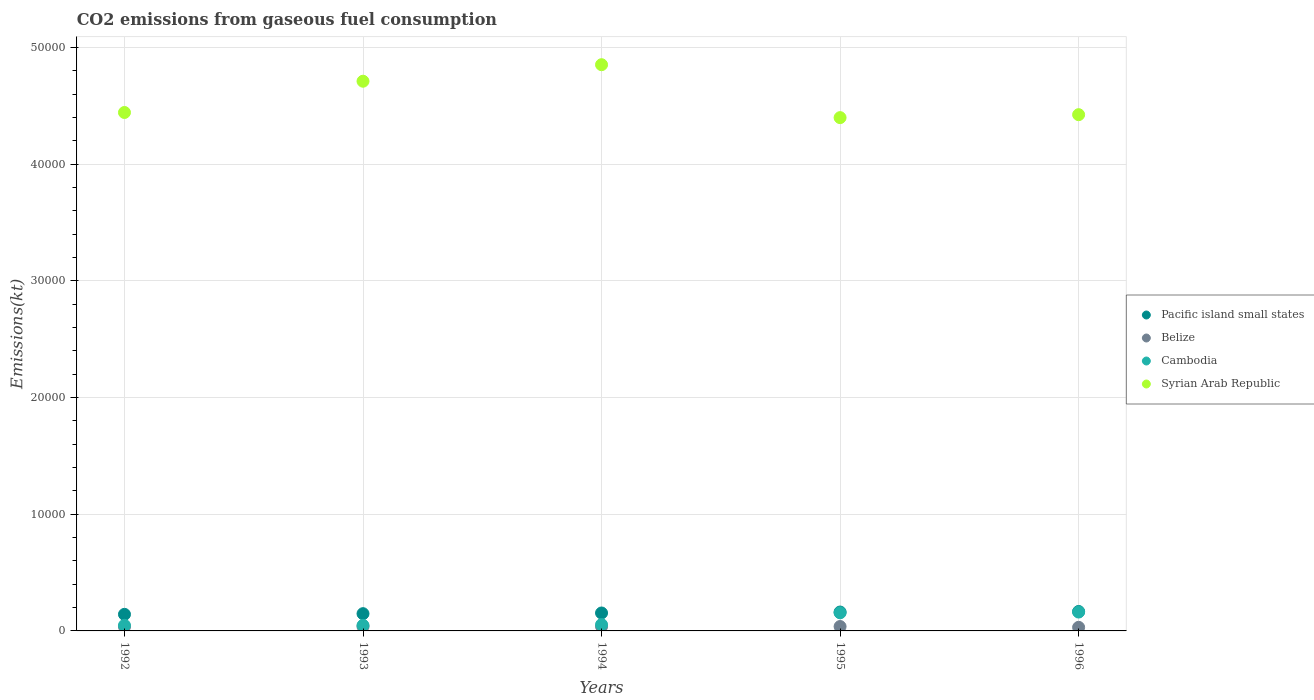Is the number of dotlines equal to the number of legend labels?
Your answer should be very brief. Yes. What is the amount of CO2 emitted in Syrian Arab Republic in 1993?
Offer a terse response. 4.71e+04. Across all years, what is the maximum amount of CO2 emitted in Syrian Arab Republic?
Your answer should be compact. 4.85e+04. Across all years, what is the minimum amount of CO2 emitted in Cambodia?
Keep it short and to the point. 476.71. In which year was the amount of CO2 emitted in Syrian Arab Republic maximum?
Make the answer very short. 1994. What is the total amount of CO2 emitted in Cambodia in the graph?
Keep it short and to the point. 4660.76. What is the difference between the amount of CO2 emitted in Belize in 1993 and that in 1994?
Provide a short and direct response. 3.67. What is the difference between the amount of CO2 emitted in Belize in 1993 and the amount of CO2 emitted in Cambodia in 1992?
Ensure brevity in your answer.  -99.01. What is the average amount of CO2 emitted in Pacific island small states per year?
Your response must be concise. 1544.2. In the year 1992, what is the difference between the amount of CO2 emitted in Pacific island small states and amount of CO2 emitted in Cambodia?
Your answer should be compact. 943.74. In how many years, is the amount of CO2 emitted in Syrian Arab Republic greater than 4000 kt?
Provide a succinct answer. 5. What is the ratio of the amount of CO2 emitted in Belize in 1992 to that in 1995?
Offer a very short reply. 0.94. Is the amount of CO2 emitted in Syrian Arab Republic in 1993 less than that in 1994?
Offer a very short reply. Yes. Is the difference between the amount of CO2 emitted in Pacific island small states in 1993 and 1995 greater than the difference between the amount of CO2 emitted in Cambodia in 1993 and 1995?
Offer a very short reply. Yes. What is the difference between the highest and the second highest amount of CO2 emitted in Belize?
Your answer should be compact. 0. What is the difference between the highest and the lowest amount of CO2 emitted in Pacific island small states?
Give a very brief answer. 245.17. Is the sum of the amount of CO2 emitted in Cambodia in 1992 and 1993 greater than the maximum amount of CO2 emitted in Belize across all years?
Your answer should be compact. Yes. Is it the case that in every year, the sum of the amount of CO2 emitted in Syrian Arab Republic and amount of CO2 emitted in Pacific island small states  is greater than the sum of amount of CO2 emitted in Cambodia and amount of CO2 emitted in Belize?
Provide a short and direct response. Yes. Is it the case that in every year, the sum of the amount of CO2 emitted in Syrian Arab Republic and amount of CO2 emitted in Pacific island small states  is greater than the amount of CO2 emitted in Cambodia?
Provide a succinct answer. Yes. Does the amount of CO2 emitted in Pacific island small states monotonically increase over the years?
Your response must be concise. Yes. Is the amount of CO2 emitted in Pacific island small states strictly greater than the amount of CO2 emitted in Syrian Arab Republic over the years?
Offer a very short reply. No. How many years are there in the graph?
Ensure brevity in your answer.  5. What is the difference between two consecutive major ticks on the Y-axis?
Ensure brevity in your answer.  10000. Does the graph contain any zero values?
Provide a short and direct response. No. Where does the legend appear in the graph?
Offer a terse response. Center right. How are the legend labels stacked?
Make the answer very short. Vertical. What is the title of the graph?
Offer a very short reply. CO2 emissions from gaseous fuel consumption. Does "Jamaica" appear as one of the legend labels in the graph?
Your response must be concise. No. What is the label or title of the X-axis?
Your response must be concise. Years. What is the label or title of the Y-axis?
Your answer should be compact. Emissions(kt). What is the Emissions(kt) in Pacific island small states in 1992?
Provide a short and direct response. 1420.45. What is the Emissions(kt) in Belize in 1992?
Ensure brevity in your answer.  355.7. What is the Emissions(kt) of Cambodia in 1992?
Make the answer very short. 476.71. What is the Emissions(kt) of Syrian Arab Republic in 1992?
Your response must be concise. 4.44e+04. What is the Emissions(kt) in Pacific island small states in 1993?
Ensure brevity in your answer.  1478.82. What is the Emissions(kt) of Belize in 1993?
Offer a very short reply. 377.7. What is the Emissions(kt) in Cambodia in 1993?
Your response must be concise. 476.71. What is the Emissions(kt) in Syrian Arab Republic in 1993?
Offer a terse response. 4.71e+04. What is the Emissions(kt) of Pacific island small states in 1994?
Your answer should be very brief. 1537.2. What is the Emissions(kt) in Belize in 1994?
Your response must be concise. 374.03. What is the Emissions(kt) of Cambodia in 1994?
Make the answer very short. 539.05. What is the Emissions(kt) in Syrian Arab Republic in 1994?
Provide a short and direct response. 4.85e+04. What is the Emissions(kt) of Pacific island small states in 1995?
Ensure brevity in your answer.  1618.92. What is the Emissions(kt) in Belize in 1995?
Offer a very short reply. 377.7. What is the Emissions(kt) in Cambodia in 1995?
Your answer should be compact. 1551.14. What is the Emissions(kt) of Syrian Arab Republic in 1995?
Your answer should be compact. 4.40e+04. What is the Emissions(kt) in Pacific island small states in 1996?
Keep it short and to the point. 1665.62. What is the Emissions(kt) of Belize in 1996?
Provide a short and direct response. 308.03. What is the Emissions(kt) of Cambodia in 1996?
Give a very brief answer. 1617.15. What is the Emissions(kt) of Syrian Arab Republic in 1996?
Make the answer very short. 4.42e+04. Across all years, what is the maximum Emissions(kt) of Pacific island small states?
Offer a terse response. 1665.62. Across all years, what is the maximum Emissions(kt) of Belize?
Provide a succinct answer. 377.7. Across all years, what is the maximum Emissions(kt) in Cambodia?
Offer a terse response. 1617.15. Across all years, what is the maximum Emissions(kt) in Syrian Arab Republic?
Make the answer very short. 4.85e+04. Across all years, what is the minimum Emissions(kt) of Pacific island small states?
Offer a very short reply. 1420.45. Across all years, what is the minimum Emissions(kt) of Belize?
Offer a terse response. 308.03. Across all years, what is the minimum Emissions(kt) in Cambodia?
Give a very brief answer. 476.71. Across all years, what is the minimum Emissions(kt) of Syrian Arab Republic?
Ensure brevity in your answer.  4.40e+04. What is the total Emissions(kt) in Pacific island small states in the graph?
Give a very brief answer. 7721.02. What is the total Emissions(kt) of Belize in the graph?
Your answer should be very brief. 1793.16. What is the total Emissions(kt) of Cambodia in the graph?
Offer a very short reply. 4660.76. What is the total Emissions(kt) in Syrian Arab Republic in the graph?
Your answer should be compact. 2.28e+05. What is the difference between the Emissions(kt) in Pacific island small states in 1992 and that in 1993?
Ensure brevity in your answer.  -58.37. What is the difference between the Emissions(kt) of Belize in 1992 and that in 1993?
Ensure brevity in your answer.  -22. What is the difference between the Emissions(kt) in Cambodia in 1992 and that in 1993?
Your answer should be very brief. 0. What is the difference between the Emissions(kt) in Syrian Arab Republic in 1992 and that in 1993?
Offer a very short reply. -2680.58. What is the difference between the Emissions(kt) in Pacific island small states in 1992 and that in 1994?
Your answer should be very brief. -116.75. What is the difference between the Emissions(kt) of Belize in 1992 and that in 1994?
Your answer should be compact. -18.34. What is the difference between the Emissions(kt) in Cambodia in 1992 and that in 1994?
Provide a succinct answer. -62.34. What is the difference between the Emissions(kt) in Syrian Arab Republic in 1992 and that in 1994?
Provide a short and direct response. -4096.04. What is the difference between the Emissions(kt) in Pacific island small states in 1992 and that in 1995?
Offer a very short reply. -198.47. What is the difference between the Emissions(kt) of Belize in 1992 and that in 1995?
Make the answer very short. -22. What is the difference between the Emissions(kt) in Cambodia in 1992 and that in 1995?
Ensure brevity in your answer.  -1074.43. What is the difference between the Emissions(kt) in Syrian Arab Republic in 1992 and that in 1995?
Provide a succinct answer. 440.04. What is the difference between the Emissions(kt) of Pacific island small states in 1992 and that in 1996?
Ensure brevity in your answer.  -245.17. What is the difference between the Emissions(kt) of Belize in 1992 and that in 1996?
Provide a short and direct response. 47.67. What is the difference between the Emissions(kt) of Cambodia in 1992 and that in 1996?
Your response must be concise. -1140.44. What is the difference between the Emissions(kt) in Syrian Arab Republic in 1992 and that in 1996?
Your answer should be compact. 187.02. What is the difference between the Emissions(kt) of Pacific island small states in 1993 and that in 1994?
Your answer should be very brief. -58.37. What is the difference between the Emissions(kt) in Belize in 1993 and that in 1994?
Provide a succinct answer. 3.67. What is the difference between the Emissions(kt) of Cambodia in 1993 and that in 1994?
Provide a succinct answer. -62.34. What is the difference between the Emissions(kt) of Syrian Arab Republic in 1993 and that in 1994?
Give a very brief answer. -1415.46. What is the difference between the Emissions(kt) in Pacific island small states in 1993 and that in 1995?
Keep it short and to the point. -140.1. What is the difference between the Emissions(kt) of Cambodia in 1993 and that in 1995?
Offer a terse response. -1074.43. What is the difference between the Emissions(kt) of Syrian Arab Republic in 1993 and that in 1995?
Your response must be concise. 3120.62. What is the difference between the Emissions(kt) in Pacific island small states in 1993 and that in 1996?
Provide a short and direct response. -186.8. What is the difference between the Emissions(kt) in Belize in 1993 and that in 1996?
Provide a short and direct response. 69.67. What is the difference between the Emissions(kt) in Cambodia in 1993 and that in 1996?
Offer a very short reply. -1140.44. What is the difference between the Emissions(kt) of Syrian Arab Republic in 1993 and that in 1996?
Offer a very short reply. 2867.59. What is the difference between the Emissions(kt) in Pacific island small states in 1994 and that in 1995?
Offer a terse response. -81.72. What is the difference between the Emissions(kt) of Belize in 1994 and that in 1995?
Your answer should be compact. -3.67. What is the difference between the Emissions(kt) in Cambodia in 1994 and that in 1995?
Ensure brevity in your answer.  -1012.09. What is the difference between the Emissions(kt) of Syrian Arab Republic in 1994 and that in 1995?
Ensure brevity in your answer.  4536.08. What is the difference between the Emissions(kt) of Pacific island small states in 1994 and that in 1996?
Provide a short and direct response. -128.42. What is the difference between the Emissions(kt) of Belize in 1994 and that in 1996?
Your response must be concise. 66.01. What is the difference between the Emissions(kt) in Cambodia in 1994 and that in 1996?
Make the answer very short. -1078.1. What is the difference between the Emissions(kt) in Syrian Arab Republic in 1994 and that in 1996?
Give a very brief answer. 4283.06. What is the difference between the Emissions(kt) of Pacific island small states in 1995 and that in 1996?
Ensure brevity in your answer.  -46.7. What is the difference between the Emissions(kt) in Belize in 1995 and that in 1996?
Offer a very short reply. 69.67. What is the difference between the Emissions(kt) of Cambodia in 1995 and that in 1996?
Ensure brevity in your answer.  -66.01. What is the difference between the Emissions(kt) of Syrian Arab Republic in 1995 and that in 1996?
Your answer should be compact. -253.02. What is the difference between the Emissions(kt) in Pacific island small states in 1992 and the Emissions(kt) in Belize in 1993?
Provide a succinct answer. 1042.75. What is the difference between the Emissions(kt) of Pacific island small states in 1992 and the Emissions(kt) of Cambodia in 1993?
Provide a short and direct response. 943.74. What is the difference between the Emissions(kt) of Pacific island small states in 1992 and the Emissions(kt) of Syrian Arab Republic in 1993?
Provide a short and direct response. -4.57e+04. What is the difference between the Emissions(kt) in Belize in 1992 and the Emissions(kt) in Cambodia in 1993?
Provide a short and direct response. -121.01. What is the difference between the Emissions(kt) in Belize in 1992 and the Emissions(kt) in Syrian Arab Republic in 1993?
Make the answer very short. -4.68e+04. What is the difference between the Emissions(kt) in Cambodia in 1992 and the Emissions(kt) in Syrian Arab Republic in 1993?
Your response must be concise. -4.66e+04. What is the difference between the Emissions(kt) of Pacific island small states in 1992 and the Emissions(kt) of Belize in 1994?
Make the answer very short. 1046.42. What is the difference between the Emissions(kt) in Pacific island small states in 1992 and the Emissions(kt) in Cambodia in 1994?
Offer a terse response. 881.4. What is the difference between the Emissions(kt) of Pacific island small states in 1992 and the Emissions(kt) of Syrian Arab Republic in 1994?
Ensure brevity in your answer.  -4.71e+04. What is the difference between the Emissions(kt) in Belize in 1992 and the Emissions(kt) in Cambodia in 1994?
Ensure brevity in your answer.  -183.35. What is the difference between the Emissions(kt) of Belize in 1992 and the Emissions(kt) of Syrian Arab Republic in 1994?
Give a very brief answer. -4.82e+04. What is the difference between the Emissions(kt) in Cambodia in 1992 and the Emissions(kt) in Syrian Arab Republic in 1994?
Provide a short and direct response. -4.81e+04. What is the difference between the Emissions(kt) of Pacific island small states in 1992 and the Emissions(kt) of Belize in 1995?
Provide a short and direct response. 1042.75. What is the difference between the Emissions(kt) of Pacific island small states in 1992 and the Emissions(kt) of Cambodia in 1995?
Keep it short and to the point. -130.69. What is the difference between the Emissions(kt) of Pacific island small states in 1992 and the Emissions(kt) of Syrian Arab Republic in 1995?
Offer a very short reply. -4.26e+04. What is the difference between the Emissions(kt) of Belize in 1992 and the Emissions(kt) of Cambodia in 1995?
Provide a short and direct response. -1195.44. What is the difference between the Emissions(kt) of Belize in 1992 and the Emissions(kt) of Syrian Arab Republic in 1995?
Offer a terse response. -4.36e+04. What is the difference between the Emissions(kt) of Cambodia in 1992 and the Emissions(kt) of Syrian Arab Republic in 1995?
Make the answer very short. -4.35e+04. What is the difference between the Emissions(kt) in Pacific island small states in 1992 and the Emissions(kt) in Belize in 1996?
Keep it short and to the point. 1112.42. What is the difference between the Emissions(kt) of Pacific island small states in 1992 and the Emissions(kt) of Cambodia in 1996?
Give a very brief answer. -196.7. What is the difference between the Emissions(kt) of Pacific island small states in 1992 and the Emissions(kt) of Syrian Arab Republic in 1996?
Offer a terse response. -4.28e+04. What is the difference between the Emissions(kt) of Belize in 1992 and the Emissions(kt) of Cambodia in 1996?
Your answer should be very brief. -1261.45. What is the difference between the Emissions(kt) of Belize in 1992 and the Emissions(kt) of Syrian Arab Republic in 1996?
Your response must be concise. -4.39e+04. What is the difference between the Emissions(kt) in Cambodia in 1992 and the Emissions(kt) in Syrian Arab Republic in 1996?
Your response must be concise. -4.38e+04. What is the difference between the Emissions(kt) of Pacific island small states in 1993 and the Emissions(kt) of Belize in 1994?
Your answer should be very brief. 1104.79. What is the difference between the Emissions(kt) of Pacific island small states in 1993 and the Emissions(kt) of Cambodia in 1994?
Ensure brevity in your answer.  939.78. What is the difference between the Emissions(kt) in Pacific island small states in 1993 and the Emissions(kt) in Syrian Arab Republic in 1994?
Your answer should be very brief. -4.71e+04. What is the difference between the Emissions(kt) of Belize in 1993 and the Emissions(kt) of Cambodia in 1994?
Provide a succinct answer. -161.35. What is the difference between the Emissions(kt) of Belize in 1993 and the Emissions(kt) of Syrian Arab Republic in 1994?
Provide a succinct answer. -4.82e+04. What is the difference between the Emissions(kt) in Cambodia in 1993 and the Emissions(kt) in Syrian Arab Republic in 1994?
Give a very brief answer. -4.81e+04. What is the difference between the Emissions(kt) in Pacific island small states in 1993 and the Emissions(kt) in Belize in 1995?
Make the answer very short. 1101.12. What is the difference between the Emissions(kt) of Pacific island small states in 1993 and the Emissions(kt) of Cambodia in 1995?
Provide a short and direct response. -72.32. What is the difference between the Emissions(kt) in Pacific island small states in 1993 and the Emissions(kt) in Syrian Arab Republic in 1995?
Offer a terse response. -4.25e+04. What is the difference between the Emissions(kt) in Belize in 1993 and the Emissions(kt) in Cambodia in 1995?
Your response must be concise. -1173.44. What is the difference between the Emissions(kt) in Belize in 1993 and the Emissions(kt) in Syrian Arab Republic in 1995?
Provide a succinct answer. -4.36e+04. What is the difference between the Emissions(kt) in Cambodia in 1993 and the Emissions(kt) in Syrian Arab Republic in 1995?
Provide a succinct answer. -4.35e+04. What is the difference between the Emissions(kt) in Pacific island small states in 1993 and the Emissions(kt) in Belize in 1996?
Provide a succinct answer. 1170.8. What is the difference between the Emissions(kt) of Pacific island small states in 1993 and the Emissions(kt) of Cambodia in 1996?
Offer a very short reply. -138.32. What is the difference between the Emissions(kt) of Pacific island small states in 1993 and the Emissions(kt) of Syrian Arab Republic in 1996?
Your answer should be very brief. -4.28e+04. What is the difference between the Emissions(kt) of Belize in 1993 and the Emissions(kt) of Cambodia in 1996?
Your answer should be very brief. -1239.45. What is the difference between the Emissions(kt) of Belize in 1993 and the Emissions(kt) of Syrian Arab Republic in 1996?
Ensure brevity in your answer.  -4.39e+04. What is the difference between the Emissions(kt) in Cambodia in 1993 and the Emissions(kt) in Syrian Arab Republic in 1996?
Offer a terse response. -4.38e+04. What is the difference between the Emissions(kt) of Pacific island small states in 1994 and the Emissions(kt) of Belize in 1995?
Your answer should be very brief. 1159.5. What is the difference between the Emissions(kt) in Pacific island small states in 1994 and the Emissions(kt) in Cambodia in 1995?
Provide a succinct answer. -13.94. What is the difference between the Emissions(kt) of Pacific island small states in 1994 and the Emissions(kt) of Syrian Arab Republic in 1995?
Provide a short and direct response. -4.25e+04. What is the difference between the Emissions(kt) in Belize in 1994 and the Emissions(kt) in Cambodia in 1995?
Your response must be concise. -1177.11. What is the difference between the Emissions(kt) of Belize in 1994 and the Emissions(kt) of Syrian Arab Republic in 1995?
Offer a very short reply. -4.36e+04. What is the difference between the Emissions(kt) of Cambodia in 1994 and the Emissions(kt) of Syrian Arab Republic in 1995?
Offer a very short reply. -4.35e+04. What is the difference between the Emissions(kt) of Pacific island small states in 1994 and the Emissions(kt) of Belize in 1996?
Provide a short and direct response. 1229.17. What is the difference between the Emissions(kt) in Pacific island small states in 1994 and the Emissions(kt) in Cambodia in 1996?
Give a very brief answer. -79.95. What is the difference between the Emissions(kt) of Pacific island small states in 1994 and the Emissions(kt) of Syrian Arab Republic in 1996?
Make the answer very short. -4.27e+04. What is the difference between the Emissions(kt) in Belize in 1994 and the Emissions(kt) in Cambodia in 1996?
Your answer should be compact. -1243.11. What is the difference between the Emissions(kt) of Belize in 1994 and the Emissions(kt) of Syrian Arab Republic in 1996?
Make the answer very short. -4.39e+04. What is the difference between the Emissions(kt) of Cambodia in 1994 and the Emissions(kt) of Syrian Arab Republic in 1996?
Keep it short and to the point. -4.37e+04. What is the difference between the Emissions(kt) in Pacific island small states in 1995 and the Emissions(kt) in Belize in 1996?
Provide a succinct answer. 1310.9. What is the difference between the Emissions(kt) in Pacific island small states in 1995 and the Emissions(kt) in Cambodia in 1996?
Offer a very short reply. 1.78. What is the difference between the Emissions(kt) in Pacific island small states in 1995 and the Emissions(kt) in Syrian Arab Republic in 1996?
Your answer should be very brief. -4.26e+04. What is the difference between the Emissions(kt) in Belize in 1995 and the Emissions(kt) in Cambodia in 1996?
Your answer should be compact. -1239.45. What is the difference between the Emissions(kt) in Belize in 1995 and the Emissions(kt) in Syrian Arab Republic in 1996?
Keep it short and to the point. -4.39e+04. What is the difference between the Emissions(kt) in Cambodia in 1995 and the Emissions(kt) in Syrian Arab Republic in 1996?
Your response must be concise. -4.27e+04. What is the average Emissions(kt) in Pacific island small states per year?
Offer a very short reply. 1544.2. What is the average Emissions(kt) in Belize per year?
Make the answer very short. 358.63. What is the average Emissions(kt) of Cambodia per year?
Offer a terse response. 932.15. What is the average Emissions(kt) in Syrian Arab Republic per year?
Keep it short and to the point. 4.57e+04. In the year 1992, what is the difference between the Emissions(kt) in Pacific island small states and Emissions(kt) in Belize?
Give a very brief answer. 1064.75. In the year 1992, what is the difference between the Emissions(kt) in Pacific island small states and Emissions(kt) in Cambodia?
Your answer should be very brief. 943.74. In the year 1992, what is the difference between the Emissions(kt) in Pacific island small states and Emissions(kt) in Syrian Arab Republic?
Offer a very short reply. -4.30e+04. In the year 1992, what is the difference between the Emissions(kt) in Belize and Emissions(kt) in Cambodia?
Your answer should be very brief. -121.01. In the year 1992, what is the difference between the Emissions(kt) in Belize and Emissions(kt) in Syrian Arab Republic?
Your response must be concise. -4.41e+04. In the year 1992, what is the difference between the Emissions(kt) in Cambodia and Emissions(kt) in Syrian Arab Republic?
Your answer should be very brief. -4.40e+04. In the year 1993, what is the difference between the Emissions(kt) of Pacific island small states and Emissions(kt) of Belize?
Give a very brief answer. 1101.12. In the year 1993, what is the difference between the Emissions(kt) in Pacific island small states and Emissions(kt) in Cambodia?
Make the answer very short. 1002.11. In the year 1993, what is the difference between the Emissions(kt) of Pacific island small states and Emissions(kt) of Syrian Arab Republic?
Provide a short and direct response. -4.56e+04. In the year 1993, what is the difference between the Emissions(kt) in Belize and Emissions(kt) in Cambodia?
Ensure brevity in your answer.  -99.01. In the year 1993, what is the difference between the Emissions(kt) in Belize and Emissions(kt) in Syrian Arab Republic?
Provide a succinct answer. -4.67e+04. In the year 1993, what is the difference between the Emissions(kt) of Cambodia and Emissions(kt) of Syrian Arab Republic?
Offer a very short reply. -4.66e+04. In the year 1994, what is the difference between the Emissions(kt) in Pacific island small states and Emissions(kt) in Belize?
Your response must be concise. 1163.16. In the year 1994, what is the difference between the Emissions(kt) of Pacific island small states and Emissions(kt) of Cambodia?
Your answer should be compact. 998.15. In the year 1994, what is the difference between the Emissions(kt) in Pacific island small states and Emissions(kt) in Syrian Arab Republic?
Your answer should be compact. -4.70e+04. In the year 1994, what is the difference between the Emissions(kt) of Belize and Emissions(kt) of Cambodia?
Offer a terse response. -165.01. In the year 1994, what is the difference between the Emissions(kt) of Belize and Emissions(kt) of Syrian Arab Republic?
Provide a short and direct response. -4.82e+04. In the year 1994, what is the difference between the Emissions(kt) in Cambodia and Emissions(kt) in Syrian Arab Republic?
Your answer should be compact. -4.80e+04. In the year 1995, what is the difference between the Emissions(kt) of Pacific island small states and Emissions(kt) of Belize?
Your answer should be compact. 1241.22. In the year 1995, what is the difference between the Emissions(kt) of Pacific island small states and Emissions(kt) of Cambodia?
Ensure brevity in your answer.  67.78. In the year 1995, what is the difference between the Emissions(kt) of Pacific island small states and Emissions(kt) of Syrian Arab Republic?
Ensure brevity in your answer.  -4.24e+04. In the year 1995, what is the difference between the Emissions(kt) in Belize and Emissions(kt) in Cambodia?
Offer a very short reply. -1173.44. In the year 1995, what is the difference between the Emissions(kt) of Belize and Emissions(kt) of Syrian Arab Republic?
Provide a succinct answer. -4.36e+04. In the year 1995, what is the difference between the Emissions(kt) of Cambodia and Emissions(kt) of Syrian Arab Republic?
Your answer should be compact. -4.24e+04. In the year 1996, what is the difference between the Emissions(kt) in Pacific island small states and Emissions(kt) in Belize?
Ensure brevity in your answer.  1357.6. In the year 1996, what is the difference between the Emissions(kt) of Pacific island small states and Emissions(kt) of Cambodia?
Offer a very short reply. 48.48. In the year 1996, what is the difference between the Emissions(kt) of Pacific island small states and Emissions(kt) of Syrian Arab Republic?
Your answer should be compact. -4.26e+04. In the year 1996, what is the difference between the Emissions(kt) of Belize and Emissions(kt) of Cambodia?
Provide a succinct answer. -1309.12. In the year 1996, what is the difference between the Emissions(kt) in Belize and Emissions(kt) in Syrian Arab Republic?
Provide a succinct answer. -4.39e+04. In the year 1996, what is the difference between the Emissions(kt) of Cambodia and Emissions(kt) of Syrian Arab Republic?
Provide a succinct answer. -4.26e+04. What is the ratio of the Emissions(kt) of Pacific island small states in 1992 to that in 1993?
Make the answer very short. 0.96. What is the ratio of the Emissions(kt) in Belize in 1992 to that in 1993?
Provide a short and direct response. 0.94. What is the ratio of the Emissions(kt) in Cambodia in 1992 to that in 1993?
Your response must be concise. 1. What is the ratio of the Emissions(kt) of Syrian Arab Republic in 1992 to that in 1993?
Your response must be concise. 0.94. What is the ratio of the Emissions(kt) of Pacific island small states in 1992 to that in 1994?
Provide a short and direct response. 0.92. What is the ratio of the Emissions(kt) of Belize in 1992 to that in 1994?
Give a very brief answer. 0.95. What is the ratio of the Emissions(kt) in Cambodia in 1992 to that in 1994?
Give a very brief answer. 0.88. What is the ratio of the Emissions(kt) in Syrian Arab Republic in 1992 to that in 1994?
Your answer should be compact. 0.92. What is the ratio of the Emissions(kt) of Pacific island small states in 1992 to that in 1995?
Offer a terse response. 0.88. What is the ratio of the Emissions(kt) in Belize in 1992 to that in 1995?
Offer a very short reply. 0.94. What is the ratio of the Emissions(kt) in Cambodia in 1992 to that in 1995?
Your response must be concise. 0.31. What is the ratio of the Emissions(kt) of Syrian Arab Republic in 1992 to that in 1995?
Your answer should be very brief. 1.01. What is the ratio of the Emissions(kt) in Pacific island small states in 1992 to that in 1996?
Make the answer very short. 0.85. What is the ratio of the Emissions(kt) in Belize in 1992 to that in 1996?
Provide a succinct answer. 1.15. What is the ratio of the Emissions(kt) of Cambodia in 1992 to that in 1996?
Provide a succinct answer. 0.29. What is the ratio of the Emissions(kt) in Syrian Arab Republic in 1992 to that in 1996?
Make the answer very short. 1. What is the ratio of the Emissions(kt) of Pacific island small states in 1993 to that in 1994?
Provide a succinct answer. 0.96. What is the ratio of the Emissions(kt) of Belize in 1993 to that in 1994?
Offer a very short reply. 1.01. What is the ratio of the Emissions(kt) of Cambodia in 1993 to that in 1994?
Give a very brief answer. 0.88. What is the ratio of the Emissions(kt) of Syrian Arab Republic in 1993 to that in 1994?
Keep it short and to the point. 0.97. What is the ratio of the Emissions(kt) in Pacific island small states in 1993 to that in 1995?
Provide a succinct answer. 0.91. What is the ratio of the Emissions(kt) in Cambodia in 1993 to that in 1995?
Keep it short and to the point. 0.31. What is the ratio of the Emissions(kt) in Syrian Arab Republic in 1993 to that in 1995?
Your response must be concise. 1.07. What is the ratio of the Emissions(kt) in Pacific island small states in 1993 to that in 1996?
Provide a short and direct response. 0.89. What is the ratio of the Emissions(kt) in Belize in 1993 to that in 1996?
Provide a succinct answer. 1.23. What is the ratio of the Emissions(kt) in Cambodia in 1993 to that in 1996?
Give a very brief answer. 0.29. What is the ratio of the Emissions(kt) of Syrian Arab Republic in 1993 to that in 1996?
Keep it short and to the point. 1.06. What is the ratio of the Emissions(kt) of Pacific island small states in 1994 to that in 1995?
Provide a short and direct response. 0.95. What is the ratio of the Emissions(kt) in Belize in 1994 to that in 1995?
Your answer should be compact. 0.99. What is the ratio of the Emissions(kt) in Cambodia in 1994 to that in 1995?
Provide a short and direct response. 0.35. What is the ratio of the Emissions(kt) of Syrian Arab Republic in 1994 to that in 1995?
Your response must be concise. 1.1. What is the ratio of the Emissions(kt) of Pacific island small states in 1994 to that in 1996?
Ensure brevity in your answer.  0.92. What is the ratio of the Emissions(kt) of Belize in 1994 to that in 1996?
Keep it short and to the point. 1.21. What is the ratio of the Emissions(kt) of Cambodia in 1994 to that in 1996?
Your response must be concise. 0.33. What is the ratio of the Emissions(kt) in Syrian Arab Republic in 1994 to that in 1996?
Offer a terse response. 1.1. What is the ratio of the Emissions(kt) in Pacific island small states in 1995 to that in 1996?
Your response must be concise. 0.97. What is the ratio of the Emissions(kt) in Belize in 1995 to that in 1996?
Offer a terse response. 1.23. What is the ratio of the Emissions(kt) of Cambodia in 1995 to that in 1996?
Make the answer very short. 0.96. What is the ratio of the Emissions(kt) in Syrian Arab Republic in 1995 to that in 1996?
Give a very brief answer. 0.99. What is the difference between the highest and the second highest Emissions(kt) of Pacific island small states?
Provide a succinct answer. 46.7. What is the difference between the highest and the second highest Emissions(kt) of Belize?
Your response must be concise. 0. What is the difference between the highest and the second highest Emissions(kt) of Cambodia?
Ensure brevity in your answer.  66.01. What is the difference between the highest and the second highest Emissions(kt) of Syrian Arab Republic?
Keep it short and to the point. 1415.46. What is the difference between the highest and the lowest Emissions(kt) in Pacific island small states?
Offer a very short reply. 245.17. What is the difference between the highest and the lowest Emissions(kt) of Belize?
Provide a succinct answer. 69.67. What is the difference between the highest and the lowest Emissions(kt) in Cambodia?
Ensure brevity in your answer.  1140.44. What is the difference between the highest and the lowest Emissions(kt) in Syrian Arab Republic?
Your answer should be compact. 4536.08. 